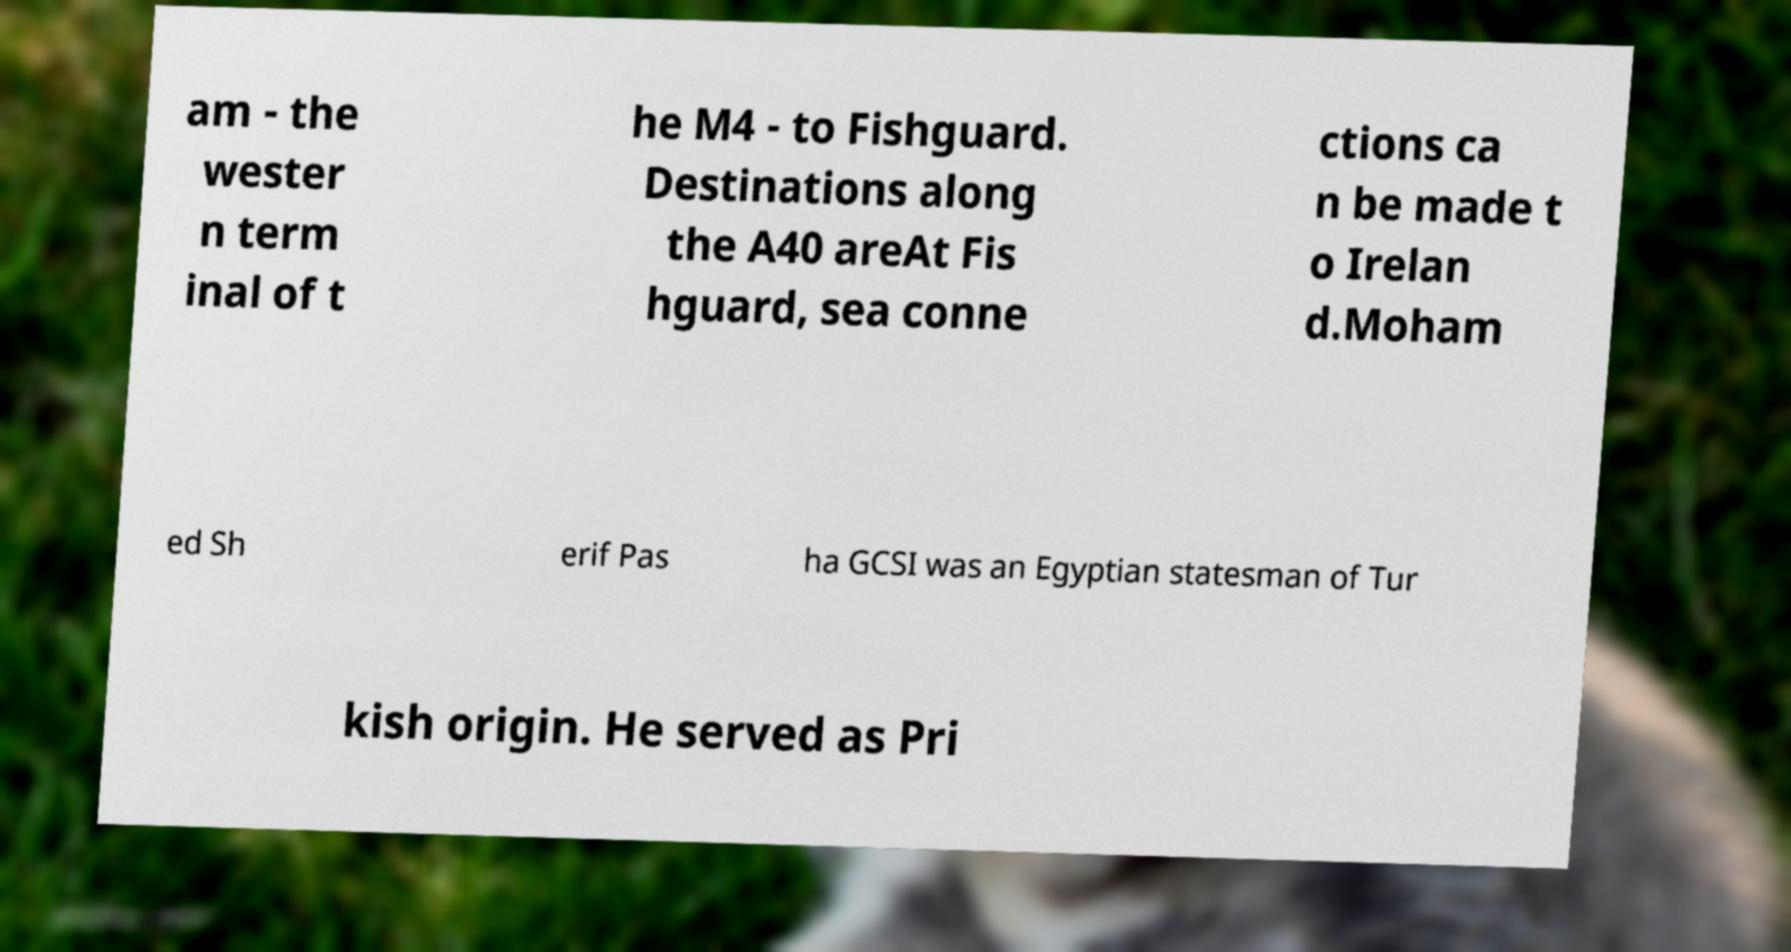Please read and relay the text visible in this image. What does it say? am - the wester n term inal of t he M4 - to Fishguard. Destinations along the A40 areAt Fis hguard, sea conne ctions ca n be made t o Irelan d.Moham ed Sh erif Pas ha GCSI was an Egyptian statesman of Tur kish origin. He served as Pri 